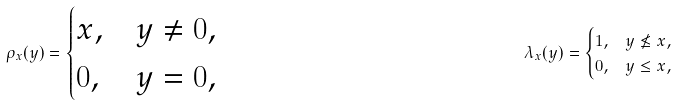<formula> <loc_0><loc_0><loc_500><loc_500>\rho _ { x } ( y ) = \begin{cases} x , & y \neq 0 , \\ 0 , & y = 0 , \end{cases} & & \lambda _ { x } ( y ) = \begin{cases} 1 , & y \nleq x , \\ 0 , & y \leq x , \end{cases}</formula> 